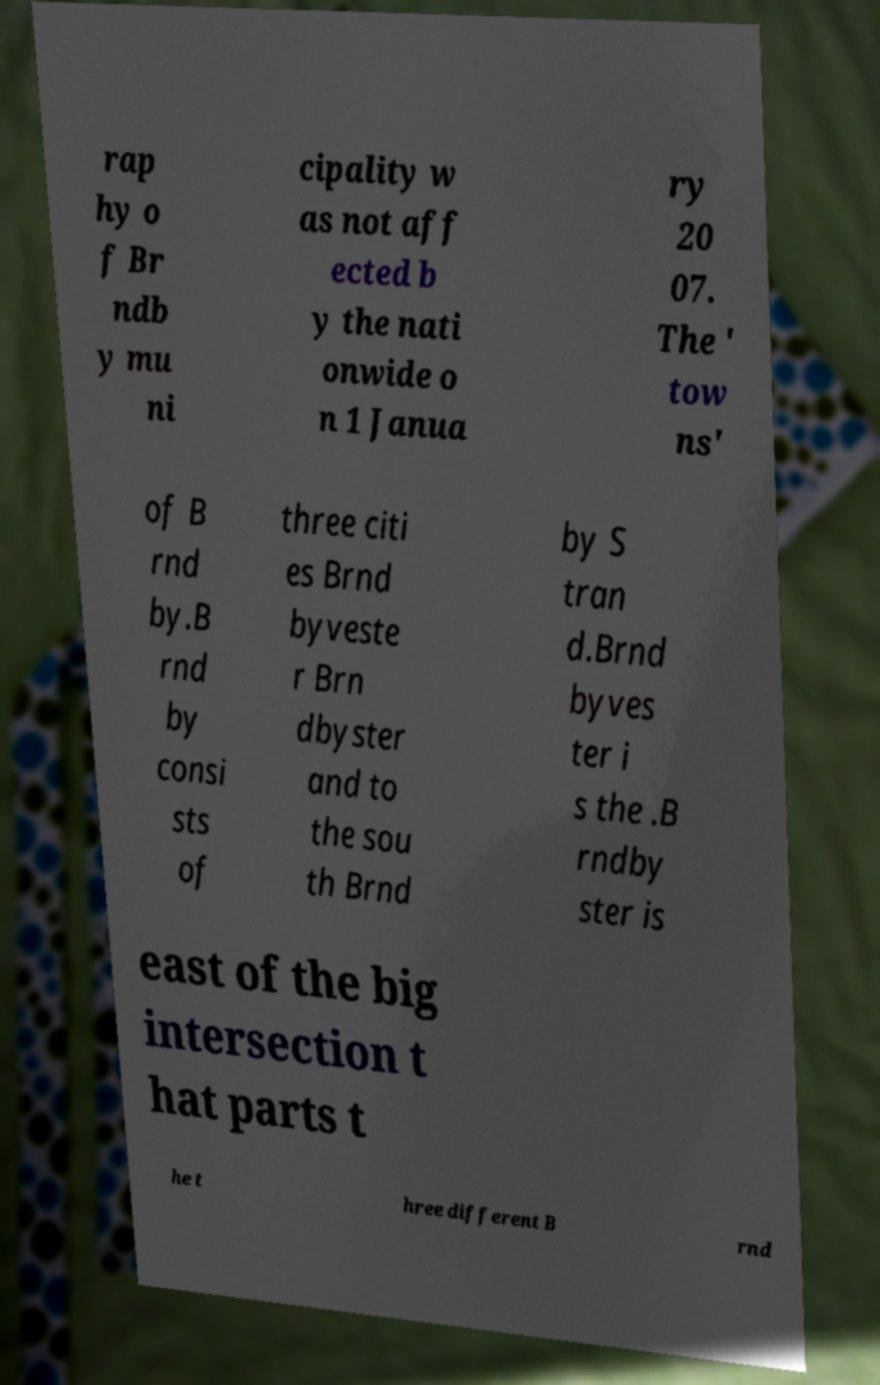What messages or text are displayed in this image? I need them in a readable, typed format. rap hy o f Br ndb y mu ni cipality w as not aff ected b y the nati onwide o n 1 Janua ry 20 07. The ' tow ns' of B rnd by.B rnd by consi sts of three citi es Brnd byveste r Brn dbyster and to the sou th Brnd by S tran d.Brnd byves ter i s the .B rndby ster is east of the big intersection t hat parts t he t hree different B rnd 